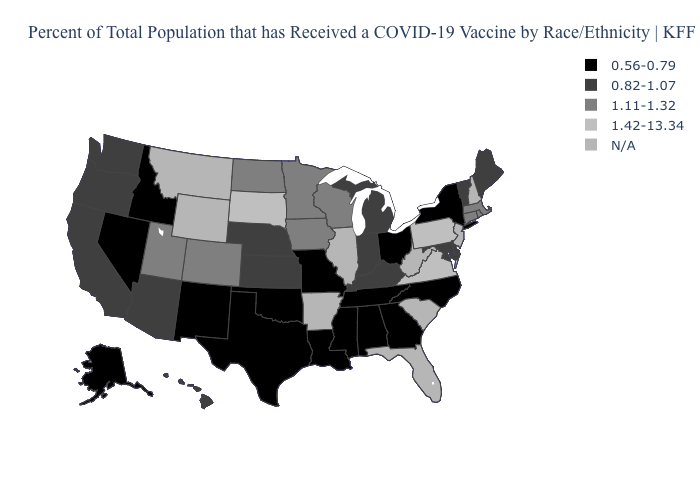What is the value of Oklahoma?
Quick response, please. 0.56-0.79. What is the lowest value in the USA?
Be succinct. 0.56-0.79. What is the value of Virginia?
Quick response, please. 1.42-13.34. What is the lowest value in states that border Delaware?
Write a very short answer. 0.82-1.07. Which states hav the highest value in the West?
Be succinct. Colorado, Utah. What is the lowest value in the USA?
Quick response, please. 0.56-0.79. Among the states that border New Mexico , which have the lowest value?
Answer briefly. Oklahoma, Texas. Is the legend a continuous bar?
Quick response, please. No. Name the states that have a value in the range 1.11-1.32?
Quick response, please. Colorado, Connecticut, Iowa, Massachusetts, Minnesota, North Dakota, Rhode Island, Utah, Wisconsin. Name the states that have a value in the range 1.11-1.32?
Write a very short answer. Colorado, Connecticut, Iowa, Massachusetts, Minnesota, North Dakota, Rhode Island, Utah, Wisconsin. Is the legend a continuous bar?
Quick response, please. No. What is the value of Rhode Island?
Keep it brief. 1.11-1.32. What is the value of North Dakota?
Quick response, please. 1.11-1.32. Name the states that have a value in the range 1.42-13.34?
Be succinct. Pennsylvania, South Dakota, Virginia. 